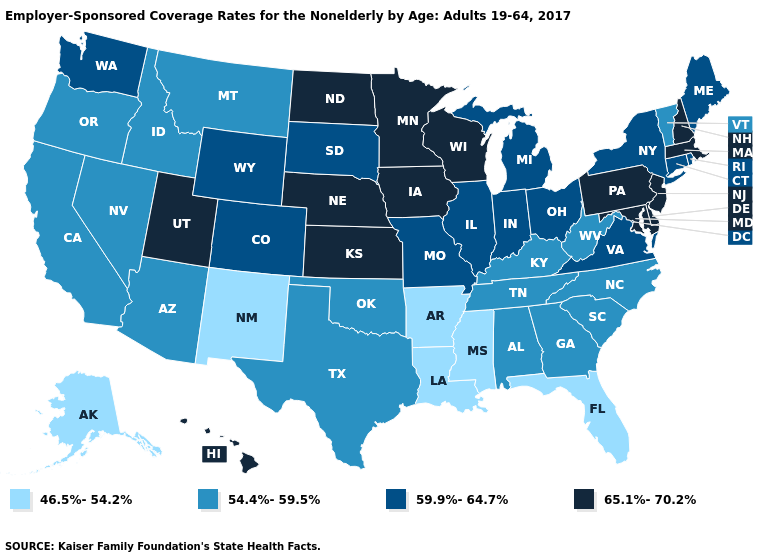What is the value of Maryland?
Concise answer only. 65.1%-70.2%. Name the states that have a value in the range 65.1%-70.2%?
Short answer required. Delaware, Hawaii, Iowa, Kansas, Maryland, Massachusetts, Minnesota, Nebraska, New Hampshire, New Jersey, North Dakota, Pennsylvania, Utah, Wisconsin. Among the states that border Illinois , which have the highest value?
Keep it brief. Iowa, Wisconsin. What is the highest value in the USA?
Concise answer only. 65.1%-70.2%. Among the states that border New Hampshire , does Vermont have the lowest value?
Be succinct. Yes. What is the highest value in the South ?
Quick response, please. 65.1%-70.2%. Does the first symbol in the legend represent the smallest category?
Answer briefly. Yes. Name the states that have a value in the range 46.5%-54.2%?
Write a very short answer. Alaska, Arkansas, Florida, Louisiana, Mississippi, New Mexico. Name the states that have a value in the range 65.1%-70.2%?
Give a very brief answer. Delaware, Hawaii, Iowa, Kansas, Maryland, Massachusetts, Minnesota, Nebraska, New Hampshire, New Jersey, North Dakota, Pennsylvania, Utah, Wisconsin. Which states have the lowest value in the South?
Short answer required. Arkansas, Florida, Louisiana, Mississippi. Name the states that have a value in the range 46.5%-54.2%?
Short answer required. Alaska, Arkansas, Florida, Louisiana, Mississippi, New Mexico. Name the states that have a value in the range 65.1%-70.2%?
Quick response, please. Delaware, Hawaii, Iowa, Kansas, Maryland, Massachusetts, Minnesota, Nebraska, New Hampshire, New Jersey, North Dakota, Pennsylvania, Utah, Wisconsin. Name the states that have a value in the range 46.5%-54.2%?
Be succinct. Alaska, Arkansas, Florida, Louisiana, Mississippi, New Mexico. What is the value of Illinois?
Short answer required. 59.9%-64.7%. What is the value of Montana?
Give a very brief answer. 54.4%-59.5%. 